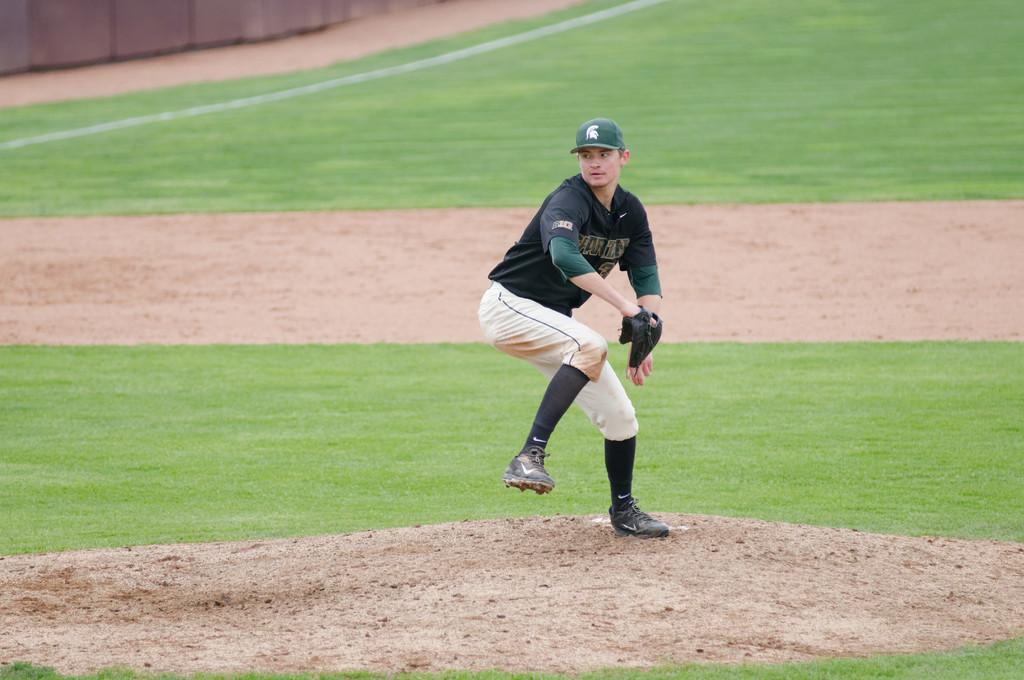Who is the main subject in the picture? There is a person in the center of the picture. What is the person wearing? The person is wearing gloves. What is the person holding? The person is holding a ball. What is the setting of the image? The setting is a baseball ground. What type of surface can be seen in the image? Soil and grass are visible in the image. What type of veil is the person wearing in the image? There is no veil present in the image; the person is wearing gloves. What advice is the person giving to the audience in the image? There is no indication in the image that the person is giving advice to an audience. 